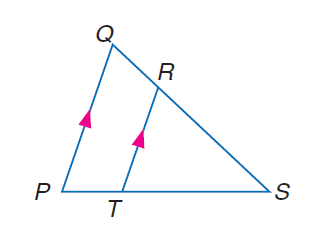Question: If R T = 15, Q P = 21, and P T = 8, find T S.
Choices:
A. 8
B. 15
C. 20
D. 21
Answer with the letter. Answer: C Question: If R T = 16, Q P = 24, and S T = 9, find P S.
Choices:
A. 6
B. 9
C. 12
D. 13.5
Answer with the letter. Answer: D Question: If P T = y - 3, P S = y + 2, R S = 12, and Q S = 16 solve for y.
Choices:
A. \frac { 3 } { 14 }
B. \frac { 2 } { 3 }
C. \frac { 3 } { 2 }
D. \frac { 14 } { 3 }
Answer with the letter. Answer: D 